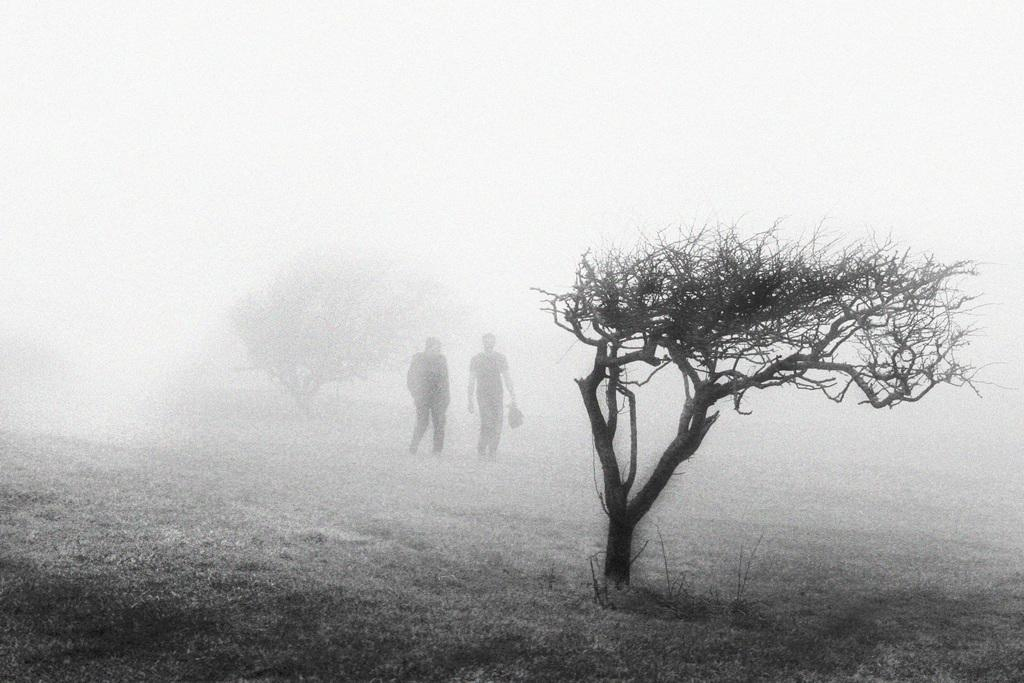Who or what can be seen in the image? There are people in the image. What type of natural elements are present in the image? There are trees on the ground in the image. What color is the background of the image? The background of the image is white. What type of roof can be seen on the crate in the image? There is no crate or roof present in the image. 